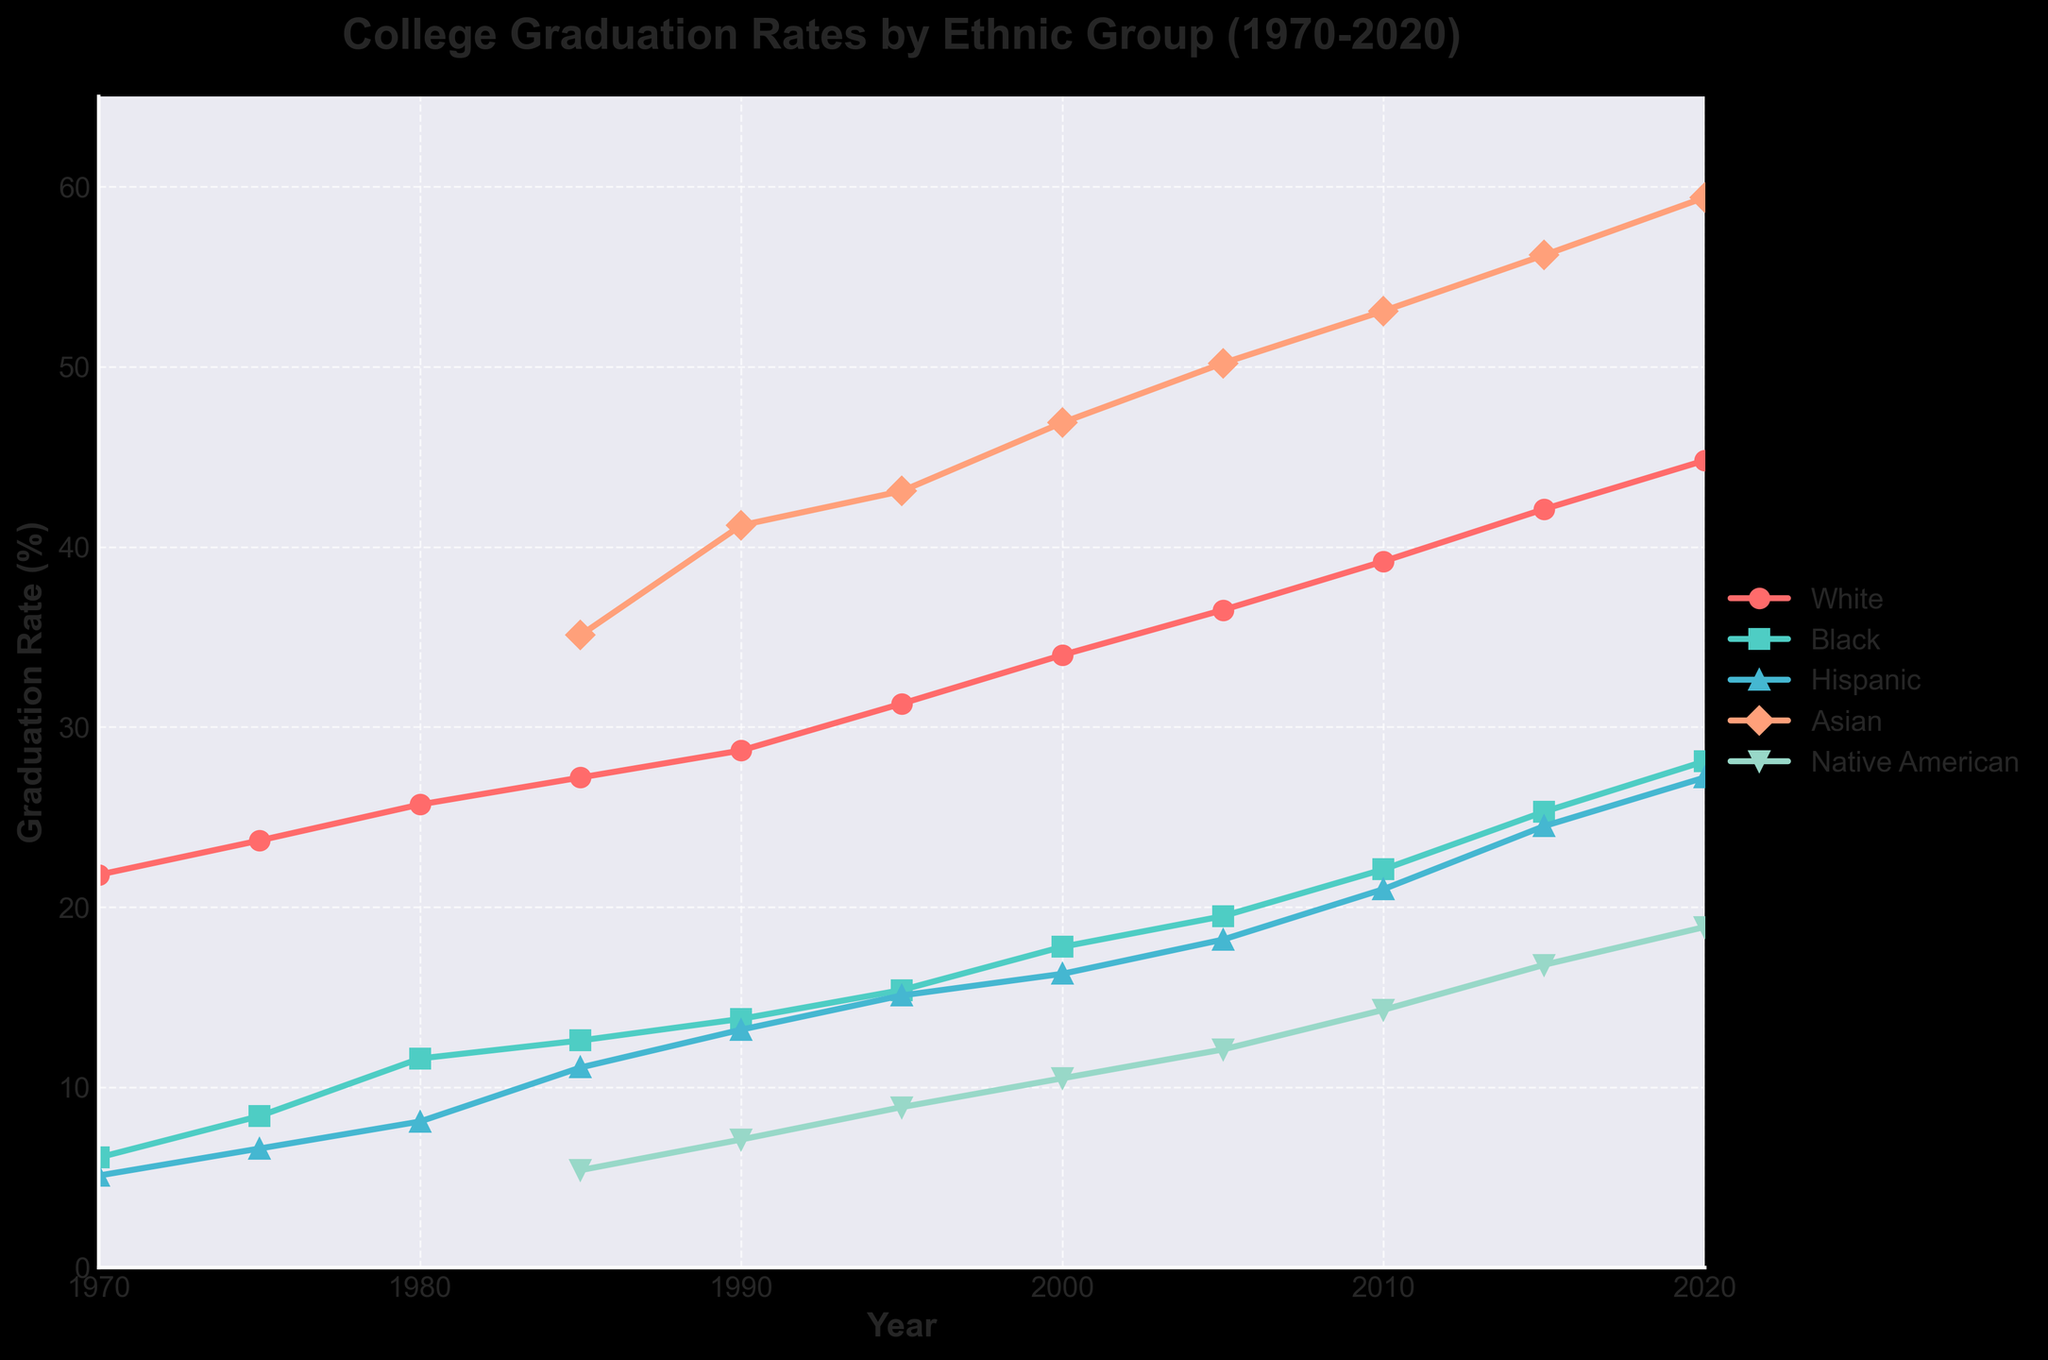What is the overall trend in graduation rates for White students from 1970 to 2020? Observing the line for White students, it starts at around 21.8% in 1970 and rises consistently to 44.8% in 2020. Therefore, the overall trend is upward.
Answer: An upward trend Which ethnic group had the highest graduation rate in 2020, and what was it? The line for Asian students has the highest point in 2020, reaching approximately 59.4%.
Answer: Asian, 59.4% How much did the graduation rate for Black students change between the years 1985 and 2000? The rate for Black students in 1985 was 12.6% and increased to 17.8% in 2000. The change is 17.8% - 12.6% = 5.2%.
Answer: 5.2% How do the graduation rates of Native American students in 1985 compare to Hispanic students in the same year? In 1985, Native American students had a graduation rate of 5.4%, while Hispanic students had a rate of 11.1%. Comparing these, the rate for Hispanic students was higher.
Answer: Hispanic rates were higher Which ethnic group saw the most significant increase in graduation rates between 1970 and 2020? Comparing the starting and ending points for each line, Asian students increased from N/A to 59.4%, Black students from 6.1% to 28.1%, Hispanic students from 5.1% to 27.2%, and White students from 21.8% to 44.8%. Asians had the largest increase.
Answer: Asian Which year had the largest graduation rate difference between White and Black students? By calculating the difference for each year, 2020 had the largest with White students at 44.8% and Black students at 28.1%. The difference is 44.8% - 28.1% = 16.7%.
Answer: 2020 What is the graduation rate for Hispanic students in 1990, and how far below White students was it? In 1990, the graduation rate for Hispanic students was 13.2%, while for White students, it was 28.7%. The difference is 28.7% - 13.2% = 15.5%.
Answer: 13.2%, 15.5% below Which ethnic group had a graduation rate of approximately 56.2% in 2015? The line for Asian students in 2015 reaches around 56.2%.
Answer: Asian Did Native American students ever surpass a 20% graduation rate by 2020? Observing the line for Native American students, their highest point in 2020 is approximately 18.9%, which is below 20%.
Answer: No In what way does the visual style of the chart help to differentiate between the ethnic groups? The chart uses different colors and markers for each ethnic group, making it easier to differentiate between them visually. Additionally, the legend provides clear labels.
Answer: Colors and markers differ 